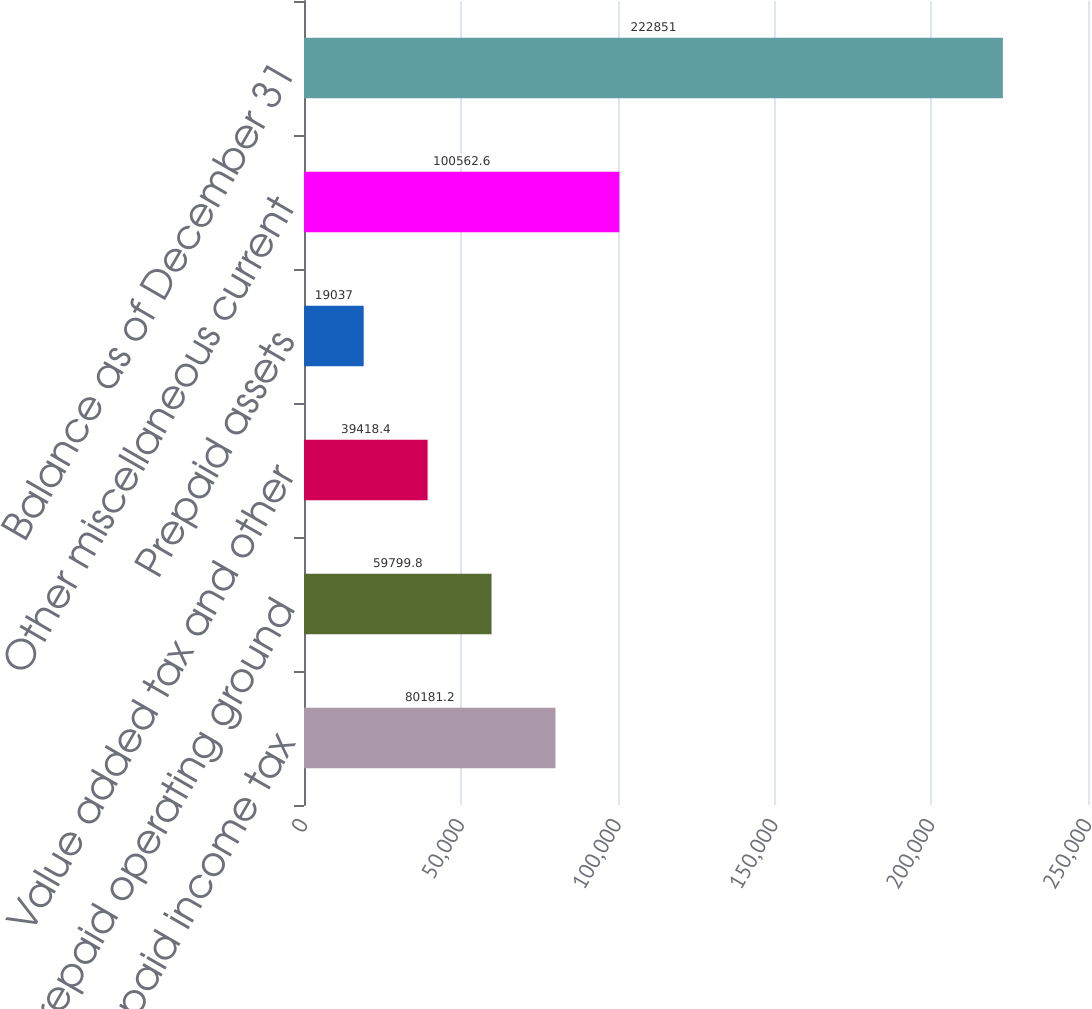<chart> <loc_0><loc_0><loc_500><loc_500><bar_chart><fcel>Prepaid income tax<fcel>Prepaid operating ground<fcel>Value added tax and other<fcel>Prepaid assets<fcel>Other miscellaneous current<fcel>Balance as of December 31<nl><fcel>80181.2<fcel>59799.8<fcel>39418.4<fcel>19037<fcel>100563<fcel>222851<nl></chart> 